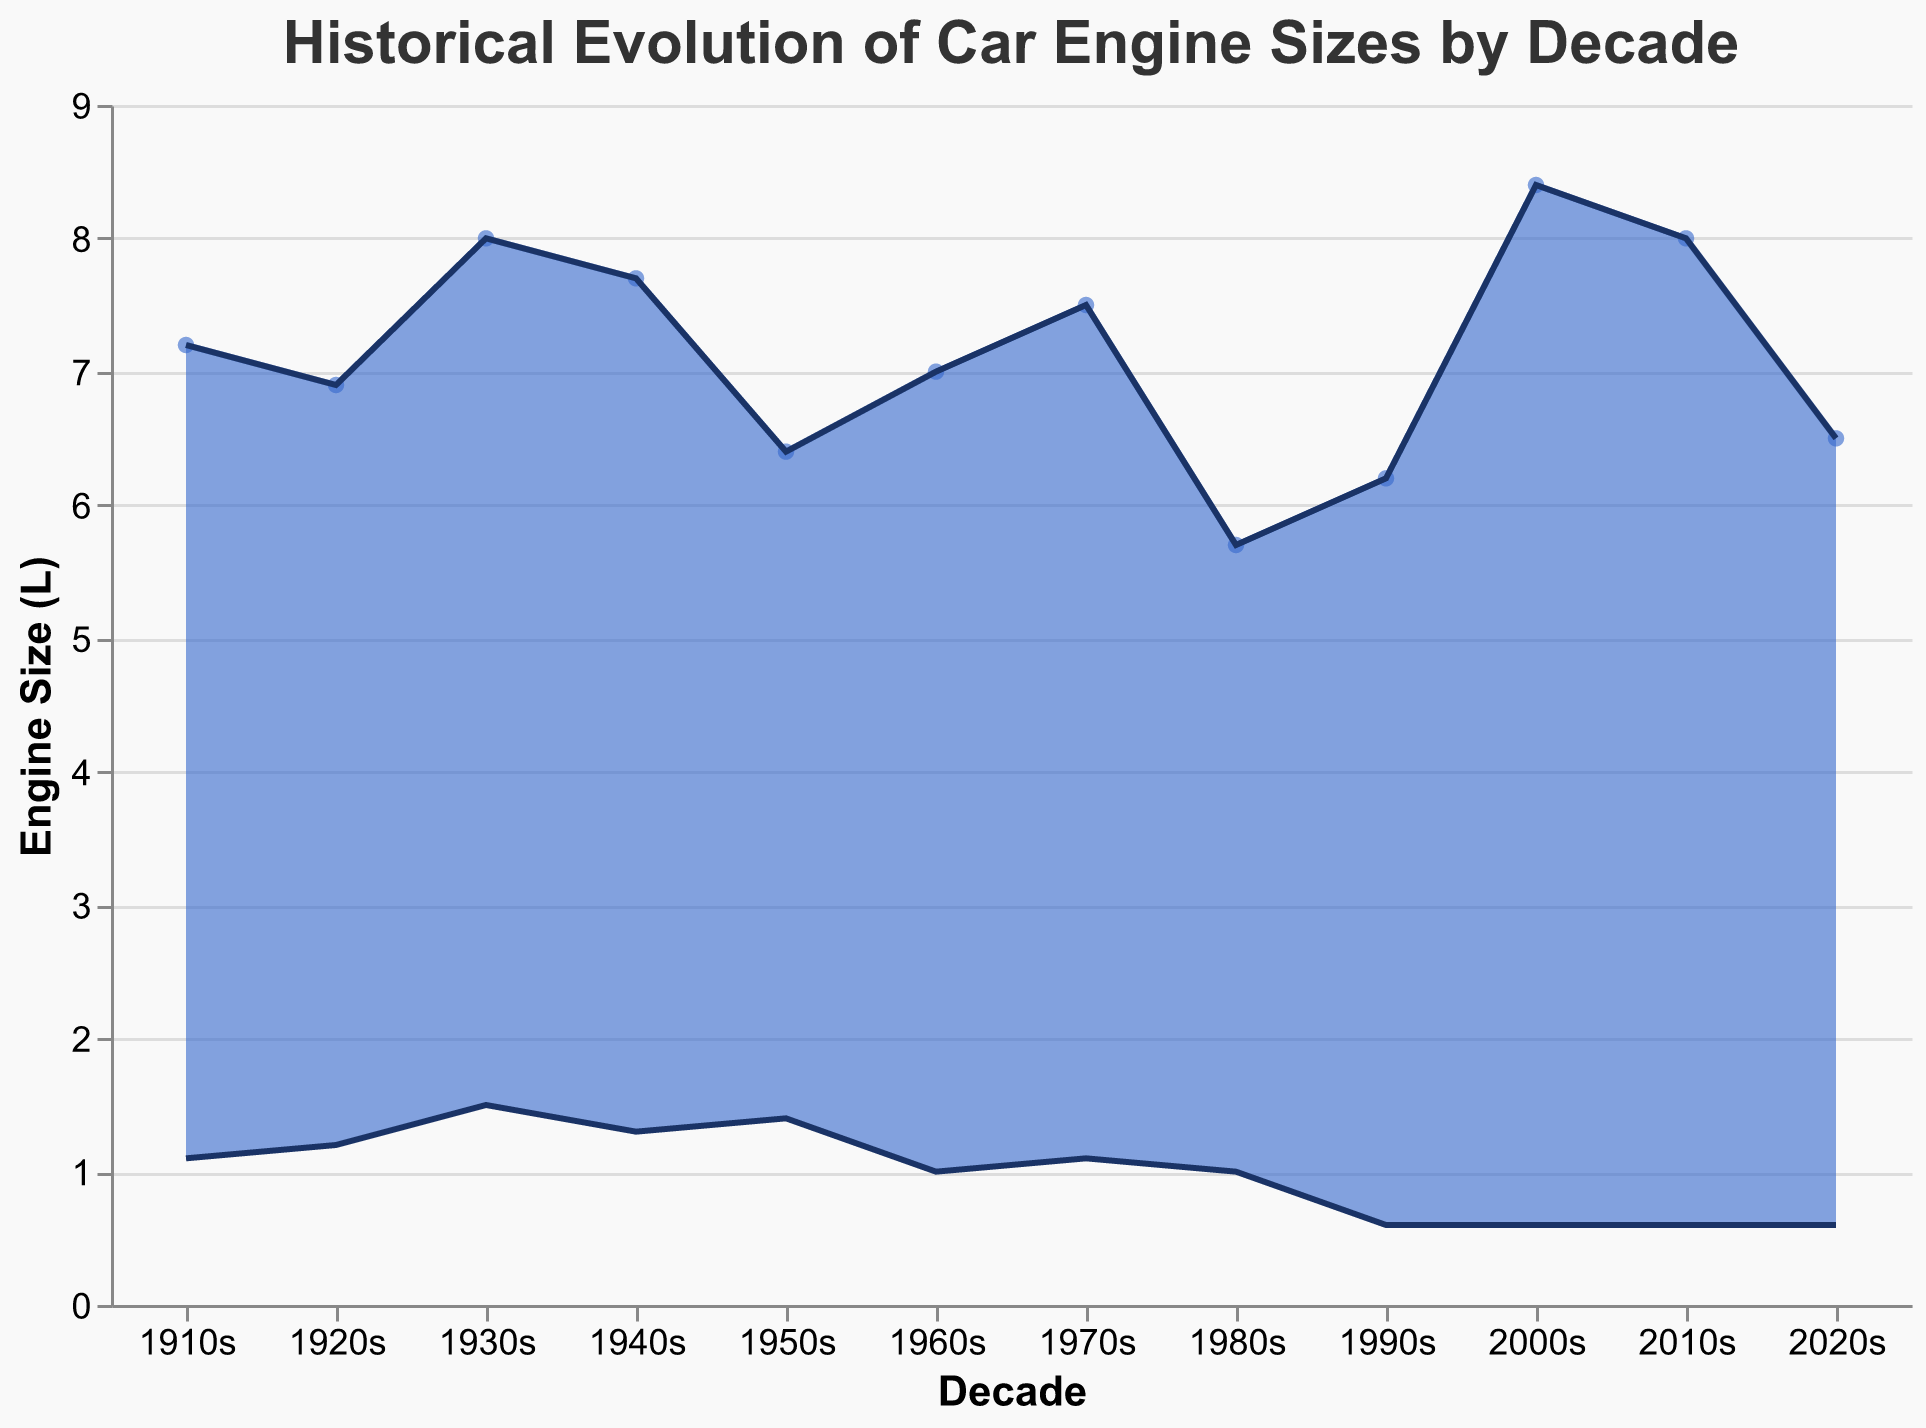What is the title of the chart? The title of the chart is located at the top center of the figure, which is clearly labeled as "Historical Evolution of Car Engine Sizes by Decade".
Answer: Historical Evolution of Car Engine Sizes by Decade What is the range of engine sizes in the 1910s? The range of engine sizes in the 1910s is shown between the minimum engine size (1.1L) and the maximum engine size (7.2L) for that decade.
Answer: 1.1L to 7.2L Which decade has the smallest minimum engine size? By scanning the chart, the smallest minimum engine size can be observed in the 1990s, 2000s, 2010s, and 2020s, all showing a minimum engine size of 0.6L.
Answer: 1990s, 2000s, 2010s, 2020s What is the maximum engine size in the 2000s? The maximum engine size for the 2000s is represented by the top point on the y-axis for that decade, which is 8.4L.
Answer: 8.4L How did the minimum engine size change from the 1910s to the 1990s? The minimum engine size can be compared between the 1910s (1.1L) and the 1990s (0.6L) by looking at the points plotted for these decades on the lower part of the chart. The change is 1.1L - 0.6L = 0.5L decrease.
Answer: Decreased by 0.5L Which decade shows the widest range of engine sizes? To find the decade with the widest range, we subtract the minimum engine size from the maximum engine size for each decade. The 2000s have the widest range from 0.6L to 8.4L, which is 8.4L - 0.6L = 7.8L.
Answer: 2000s What is the average maximum engine size in the 1930s, 1940s, and 1950s? We sum the maximum engine sizes for these decades and then divide by the number of decades. (8.0 + 7.7 + 6.4) / 3 = 22.1 / 3 = 7.37L.
Answer: 7.37L Which decade experienced the most significant increase in the minimum engine size from the previous decade? By examining changes decade by decade: 
1910s to 1920s (1.1 to 1.2L, +0.1L), 
1920s to 1930s (1.2 to 1.5L, +0.3L), 
1930s to 1940s (1.5 to 1.3L, -0.2L), 
1940s to 1950s (1.3 to 1.4L, +0.1L), 
1950s to 1960s (1.4 to 1.0L, -0.4L), 
1960s to 1970s (1.0 to 1.1L, +0.1L), 
1970s to 1980s (1.1 to 1.0L, -0.1L), 
1980s to 1990s (1.0 to 0.6L, -0.4L). 
Most significant increase is from 1920s to 1930s by +0.3L.
Answer: 1930s Between which two decades did the maximum engine size decrease the most? Compare the differences between consecutive decades for maximum engine size: 
1910s to 1920s (-0.3),
1920s to 1930s (+1.1),
1930s to 1940s (-0.3),
1940s to 1950s (-1.3),
1950s to 1960s (+0.6),
1960s to 1970s (+0.5),
1970s to 1980s (-1.8),
1980s to 1990s (+0.5),
1990s to 2000s (+2.2),
2000s to 2010s (-0.4),
2010s to 2020s (-1.5). 
The maximum decrease is from 1970s to 1980s (-1.8L).
Answer: 1970s to 1980s 